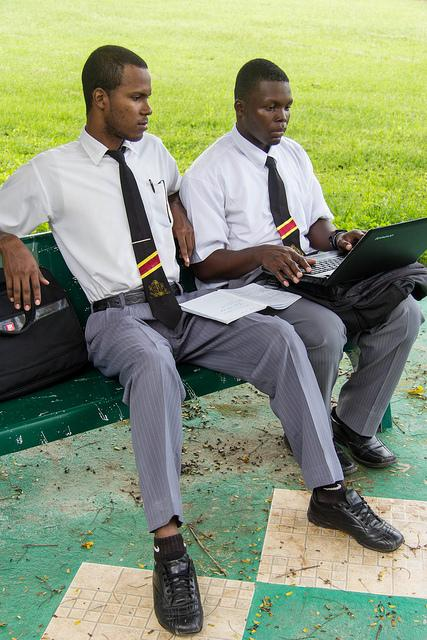What do the men's uniforms typically represent? school 